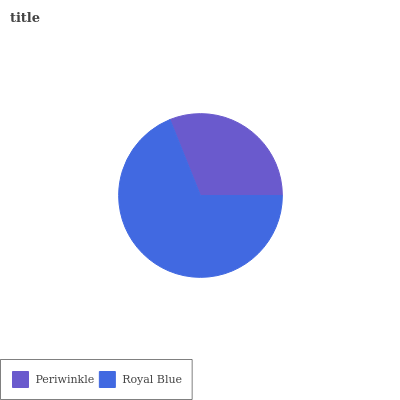Is Periwinkle the minimum?
Answer yes or no. Yes. Is Royal Blue the maximum?
Answer yes or no. Yes. Is Royal Blue the minimum?
Answer yes or no. No. Is Royal Blue greater than Periwinkle?
Answer yes or no. Yes. Is Periwinkle less than Royal Blue?
Answer yes or no. Yes. Is Periwinkle greater than Royal Blue?
Answer yes or no. No. Is Royal Blue less than Periwinkle?
Answer yes or no. No. Is Royal Blue the high median?
Answer yes or no. Yes. Is Periwinkle the low median?
Answer yes or no. Yes. Is Periwinkle the high median?
Answer yes or no. No. Is Royal Blue the low median?
Answer yes or no. No. 